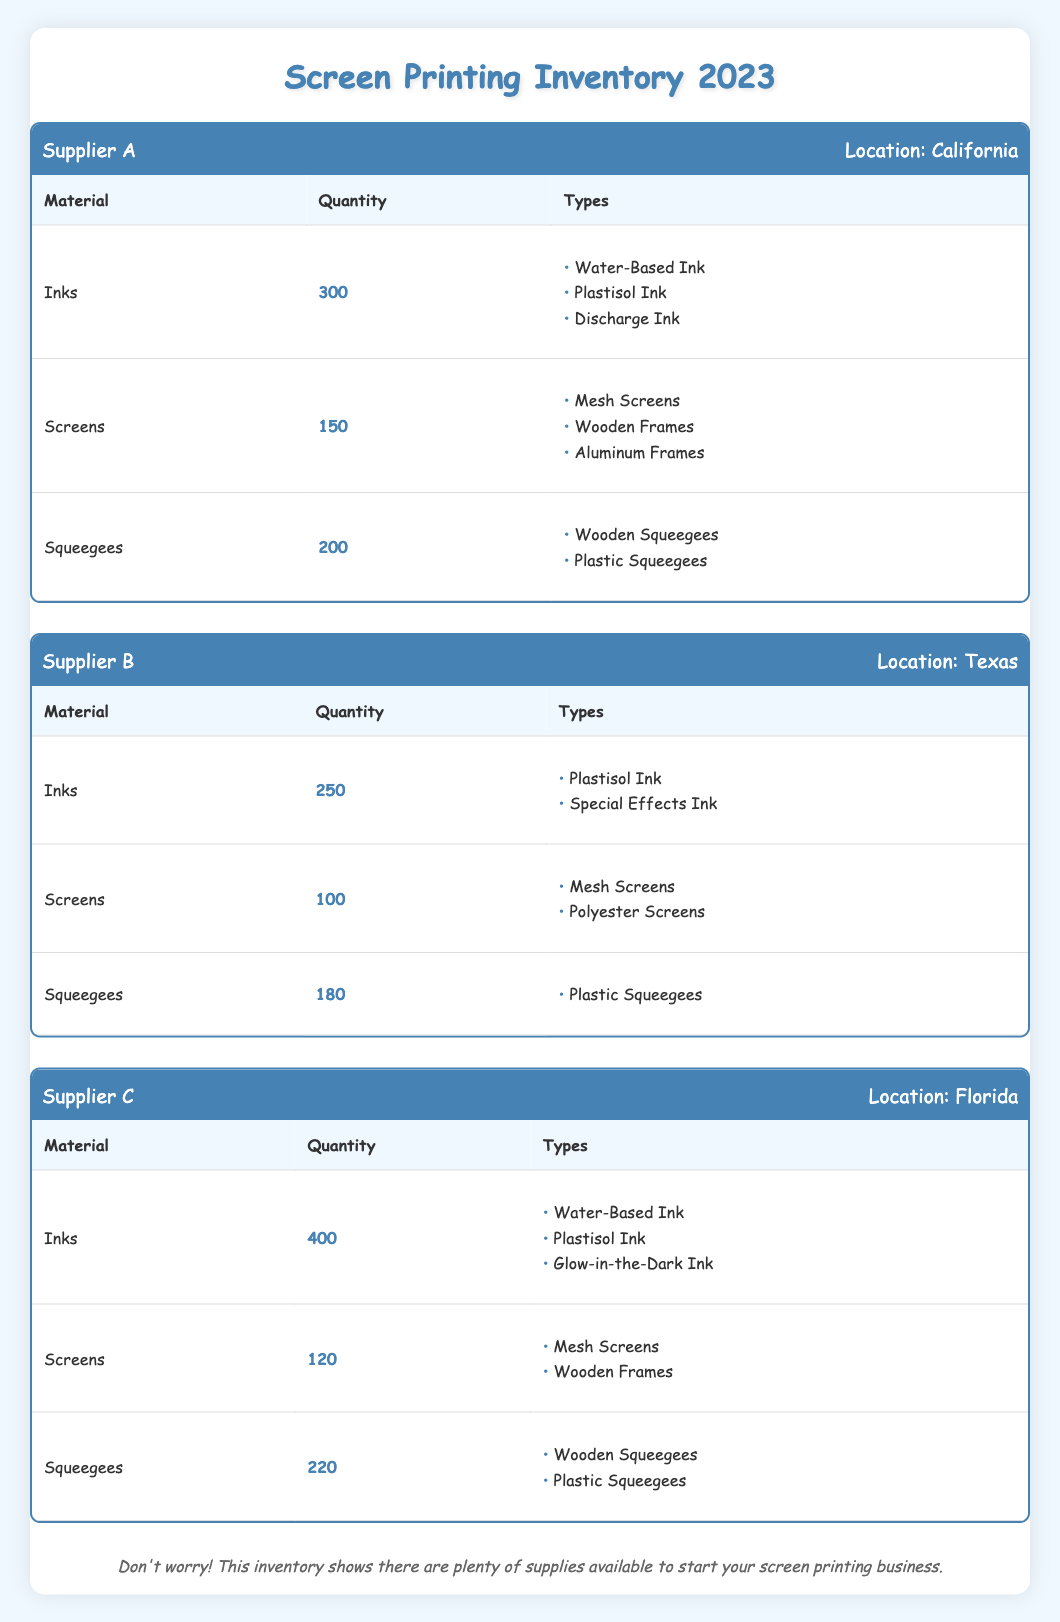What is the total quantity of inks available from all suppliers? To find the total quantity of inks, sum the quantities from each supplier. Supplier A has 300, Supplier B has 250, and Supplier C has 400. So, 300 + 250 + 400 = 950.
Answer: 950 Which supplier has the highest quantity of squeegees? By comparing the squeegee quantities: Supplier A has 200, Supplier B has 180, and Supplier C has 220. The highest is 220 from Supplier C.
Answer: Supplier C Is there any supplier that offers Glow-in-the-Dark Ink? Checking the ink types for each supplier, only Supplier C lists Glow-in-the-Dark Ink among their types. Therefore, the statement is true.
Answer: Yes What is the average quantity of screens across all suppliers? First, we find the total quantity of screens: Supplier A has 150, Supplier B has 100, and Supplier C has 120, which sums to 370. Since there are 3 suppliers, the average is 370/3 ≈ 123.33.
Answer: 123.33 Which supplier located in Florida offers the most types of inks? Supplier C, located in Florida, offers three types of inks: Water-Based Ink, Plastisol Ink, and Glow-in-the-Dark Ink. Supplier A offers three types, and Supplier B offers two. Therefore, Supplier C has the most types.
Answer: Supplier C Is there a supplier that offers both Wooden and Plastic Squeegees? Review the squeegee types: Supplier A offers Wooden and Plastic Squeegees, while Supplier C also offers both. Supplier B offers only Plastic Squeegees. This confirms the statement is true.
Answer: Yes What is the total quantity of materials (inks, screens, and squeegees) from Supplier A? To get the total, sum the materials from Supplier A: Inks (300) + Screens (150) + Squeegees (200) = 650.
Answer: 650 From which supplier can I obtain the least number of screens? A comparison of screen quantities shows Supplier A has 150, Supplier B has 100, and Supplier C has 120. Thus, Supplier B has the least.
Answer: Supplier B What is the difference in the quantity of inks between Supplier A and Supplier C? Supplier A has 300 inks, and Supplier C has 400. The difference is 400 - 300 = 100.
Answer: 100 